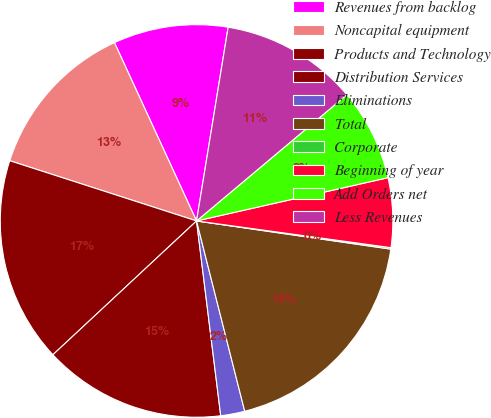<chart> <loc_0><loc_0><loc_500><loc_500><pie_chart><fcel>Revenues from backlog<fcel>Noncapital equipment<fcel>Products and Technology<fcel>Distribution Services<fcel>Eliminations<fcel>Total<fcel>Corporate<fcel>Beginning of year<fcel>Add Orders net<fcel>Less Revenues<nl><fcel>9.44%<fcel>13.17%<fcel>16.9%<fcel>15.03%<fcel>1.98%<fcel>18.76%<fcel>0.12%<fcel>5.71%<fcel>7.58%<fcel>11.31%<nl></chart> 